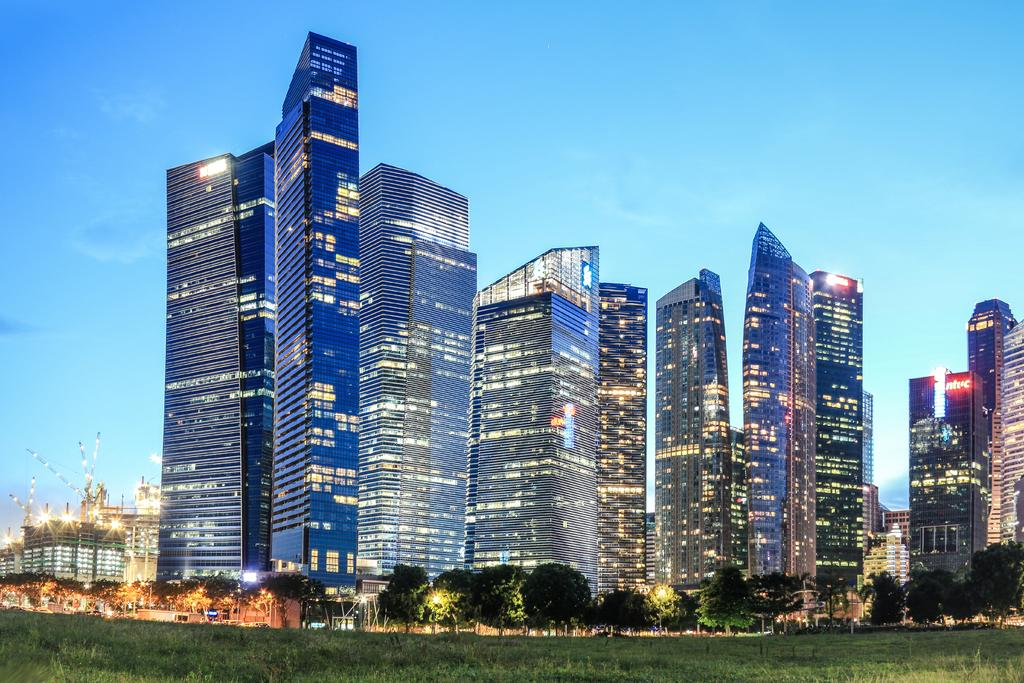At what time of day was the image captured? The image was captured in the evening. What can be seen on top of the tall towers in the image? The tall towers have lights on them in the image. What type of vegetation is present in front of the buildings in the image? There are trees and grass in front of the buildings in the image. What type of bell can be heard ringing in the image? There is no bell present or audible in the image. What health benefits can be gained from the image? The image does not convey any health benefits, as it is a visual representation and not a source of nutrition or exercise. 